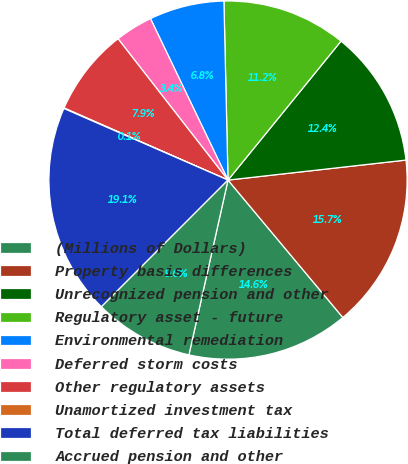Convert chart. <chart><loc_0><loc_0><loc_500><loc_500><pie_chart><fcel>(Millions of Dollars)<fcel>Property basis differences<fcel>Unrecognized pension and other<fcel>Regulatory asset - future<fcel>Environmental remediation<fcel>Deferred storm costs<fcel>Other regulatory assets<fcel>Unamortized investment tax<fcel>Total deferred tax liabilities<fcel>Accrued pension and other<nl><fcel>14.58%<fcel>15.7%<fcel>12.35%<fcel>11.23%<fcel>6.76%<fcel>3.4%<fcel>7.88%<fcel>0.05%<fcel>19.05%<fcel>8.99%<nl></chart> 